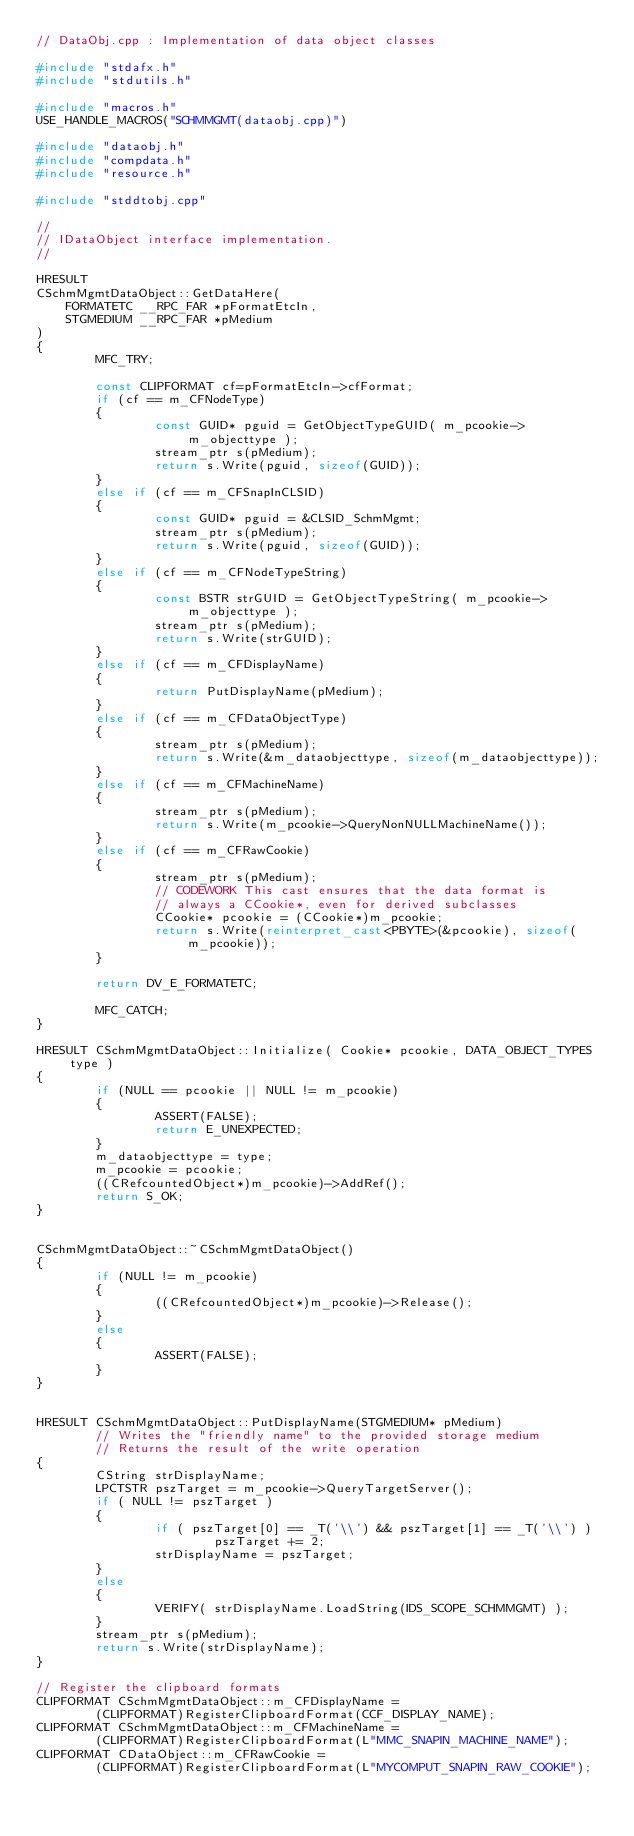Convert code to text. <code><loc_0><loc_0><loc_500><loc_500><_C++_>// DataObj.cpp : Implementation of data object classes

#include "stdafx.h"
#include "stdutils.h"

#include "macros.h"
USE_HANDLE_MACROS("SCHMMGMT(dataobj.cpp)")

#include "dataobj.h"
#include "compdata.h"
#include "resource.h"

#include "stddtobj.cpp"

//
// IDataObject interface implementation.
//

HRESULT
CSchmMgmtDataObject::GetDataHere(
    FORMATETC __RPC_FAR *pFormatEtcIn,
    STGMEDIUM __RPC_FAR *pMedium
)
{
        MFC_TRY;

        const CLIPFORMAT cf=pFormatEtcIn->cfFormat;
        if (cf == m_CFNodeType)
        {
                const GUID* pguid = GetObjectTypeGUID( m_pcookie->m_objecttype );
                stream_ptr s(pMedium);
                return s.Write(pguid, sizeof(GUID));
        }
        else if (cf == m_CFSnapInCLSID)
        {
                const GUID* pguid = &CLSID_SchmMgmt;
                stream_ptr s(pMedium);
                return s.Write(pguid, sizeof(GUID));
        }
        else if (cf == m_CFNodeTypeString)
        {
                const BSTR strGUID = GetObjectTypeString( m_pcookie->m_objecttype );
                stream_ptr s(pMedium);
                return s.Write(strGUID);
        }
        else if (cf == m_CFDisplayName)
        {
                return PutDisplayName(pMedium);
        }
        else if (cf == m_CFDataObjectType)
        {
                stream_ptr s(pMedium);
                return s.Write(&m_dataobjecttype, sizeof(m_dataobjecttype));
        }
        else if (cf == m_CFMachineName)
        {
                stream_ptr s(pMedium);
                return s.Write(m_pcookie->QueryNonNULLMachineName());
        }
        else if (cf == m_CFRawCookie)
        {
                stream_ptr s(pMedium);
                // CODEWORK This cast ensures that the data format is
                // always a CCookie*, even for derived subclasses
                CCookie* pcookie = (CCookie*)m_pcookie;
                return s.Write(reinterpret_cast<PBYTE>(&pcookie), sizeof(m_pcookie));
        }

        return DV_E_FORMATETC;

        MFC_CATCH;
}

HRESULT CSchmMgmtDataObject::Initialize( Cookie* pcookie, DATA_OBJECT_TYPES type )
{
        if (NULL == pcookie || NULL != m_pcookie)
        {
                ASSERT(FALSE);
                return E_UNEXPECTED;
        }
        m_dataobjecttype = type;
        m_pcookie = pcookie;
        ((CRefcountedObject*)m_pcookie)->AddRef();
        return S_OK;
}


CSchmMgmtDataObject::~CSchmMgmtDataObject()
{
        if (NULL != m_pcookie)
        {
                ((CRefcountedObject*)m_pcookie)->Release();
        }
        else
        {
                ASSERT(FALSE);
        }
}


HRESULT CSchmMgmtDataObject::PutDisplayName(STGMEDIUM* pMedium)
        // Writes the "friendly name" to the provided storage medium
        // Returns the result of the write operation
{
        CString strDisplayName;
        LPCTSTR pszTarget = m_pcookie->QueryTargetServer();
        if ( NULL != pszTarget )
        {
                if ( pszTarget[0] == _T('\\') && pszTarget[1] == _T('\\') )
                        pszTarget += 2;
                strDisplayName = pszTarget;
        }
        else
        {
                VERIFY( strDisplayName.LoadString(IDS_SCOPE_SCHMMGMT) );
        }
        stream_ptr s(pMedium);
        return s.Write(strDisplayName);
}

// Register the clipboard formats
CLIPFORMAT CSchmMgmtDataObject::m_CFDisplayName =
        (CLIPFORMAT)RegisterClipboardFormat(CCF_DISPLAY_NAME);
CLIPFORMAT CSchmMgmtDataObject::m_CFMachineName =
        (CLIPFORMAT)RegisterClipboardFormat(L"MMC_SNAPIN_MACHINE_NAME");
CLIPFORMAT CDataObject::m_CFRawCookie =
        (CLIPFORMAT)RegisterClipboardFormat(L"MYCOMPUT_SNAPIN_RAW_COOKIE");

</code> 